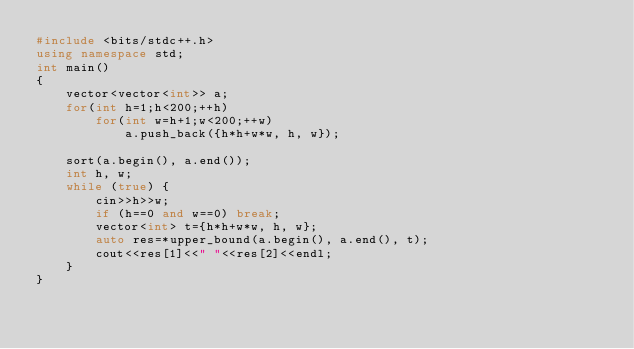Convert code to text. <code><loc_0><loc_0><loc_500><loc_500><_C++_>#include <bits/stdc++.h>
using namespace std;
int main()
{
    vector<vector<int>> a;
    for(int h=1;h<200;++h)
        for(int w=h+1;w<200;++w)
            a.push_back({h*h+w*w, h, w});

    sort(a.begin(), a.end());
    int h, w;
    while (true) {
        cin>>h>>w;
        if (h==0 and w==0) break;
        vector<int> t={h*h+w*w, h, w};
        auto res=*upper_bound(a.begin(), a.end(), t);
        cout<<res[1]<<" "<<res[2]<<endl;
    }
}</code> 